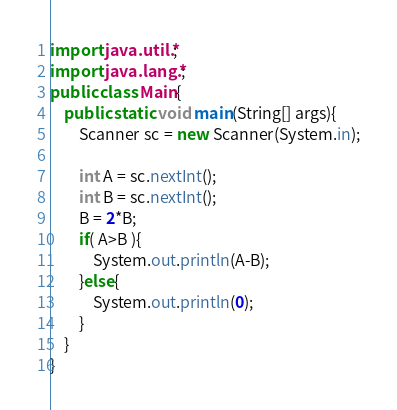Convert code to text. <code><loc_0><loc_0><loc_500><loc_500><_Java_>import java.util.*;
import java.lang.*;
public class Main{
	public static void main(String[] args){
		Scanner sc = new Scanner(System.in);
		
		int A = sc.nextInt();
		int B = sc.nextInt();
		B = 2*B;
		if( A>B ){
			System.out.println(A-B);
		}else{
			System.out.println(0);
		}
	}
}
</code> 